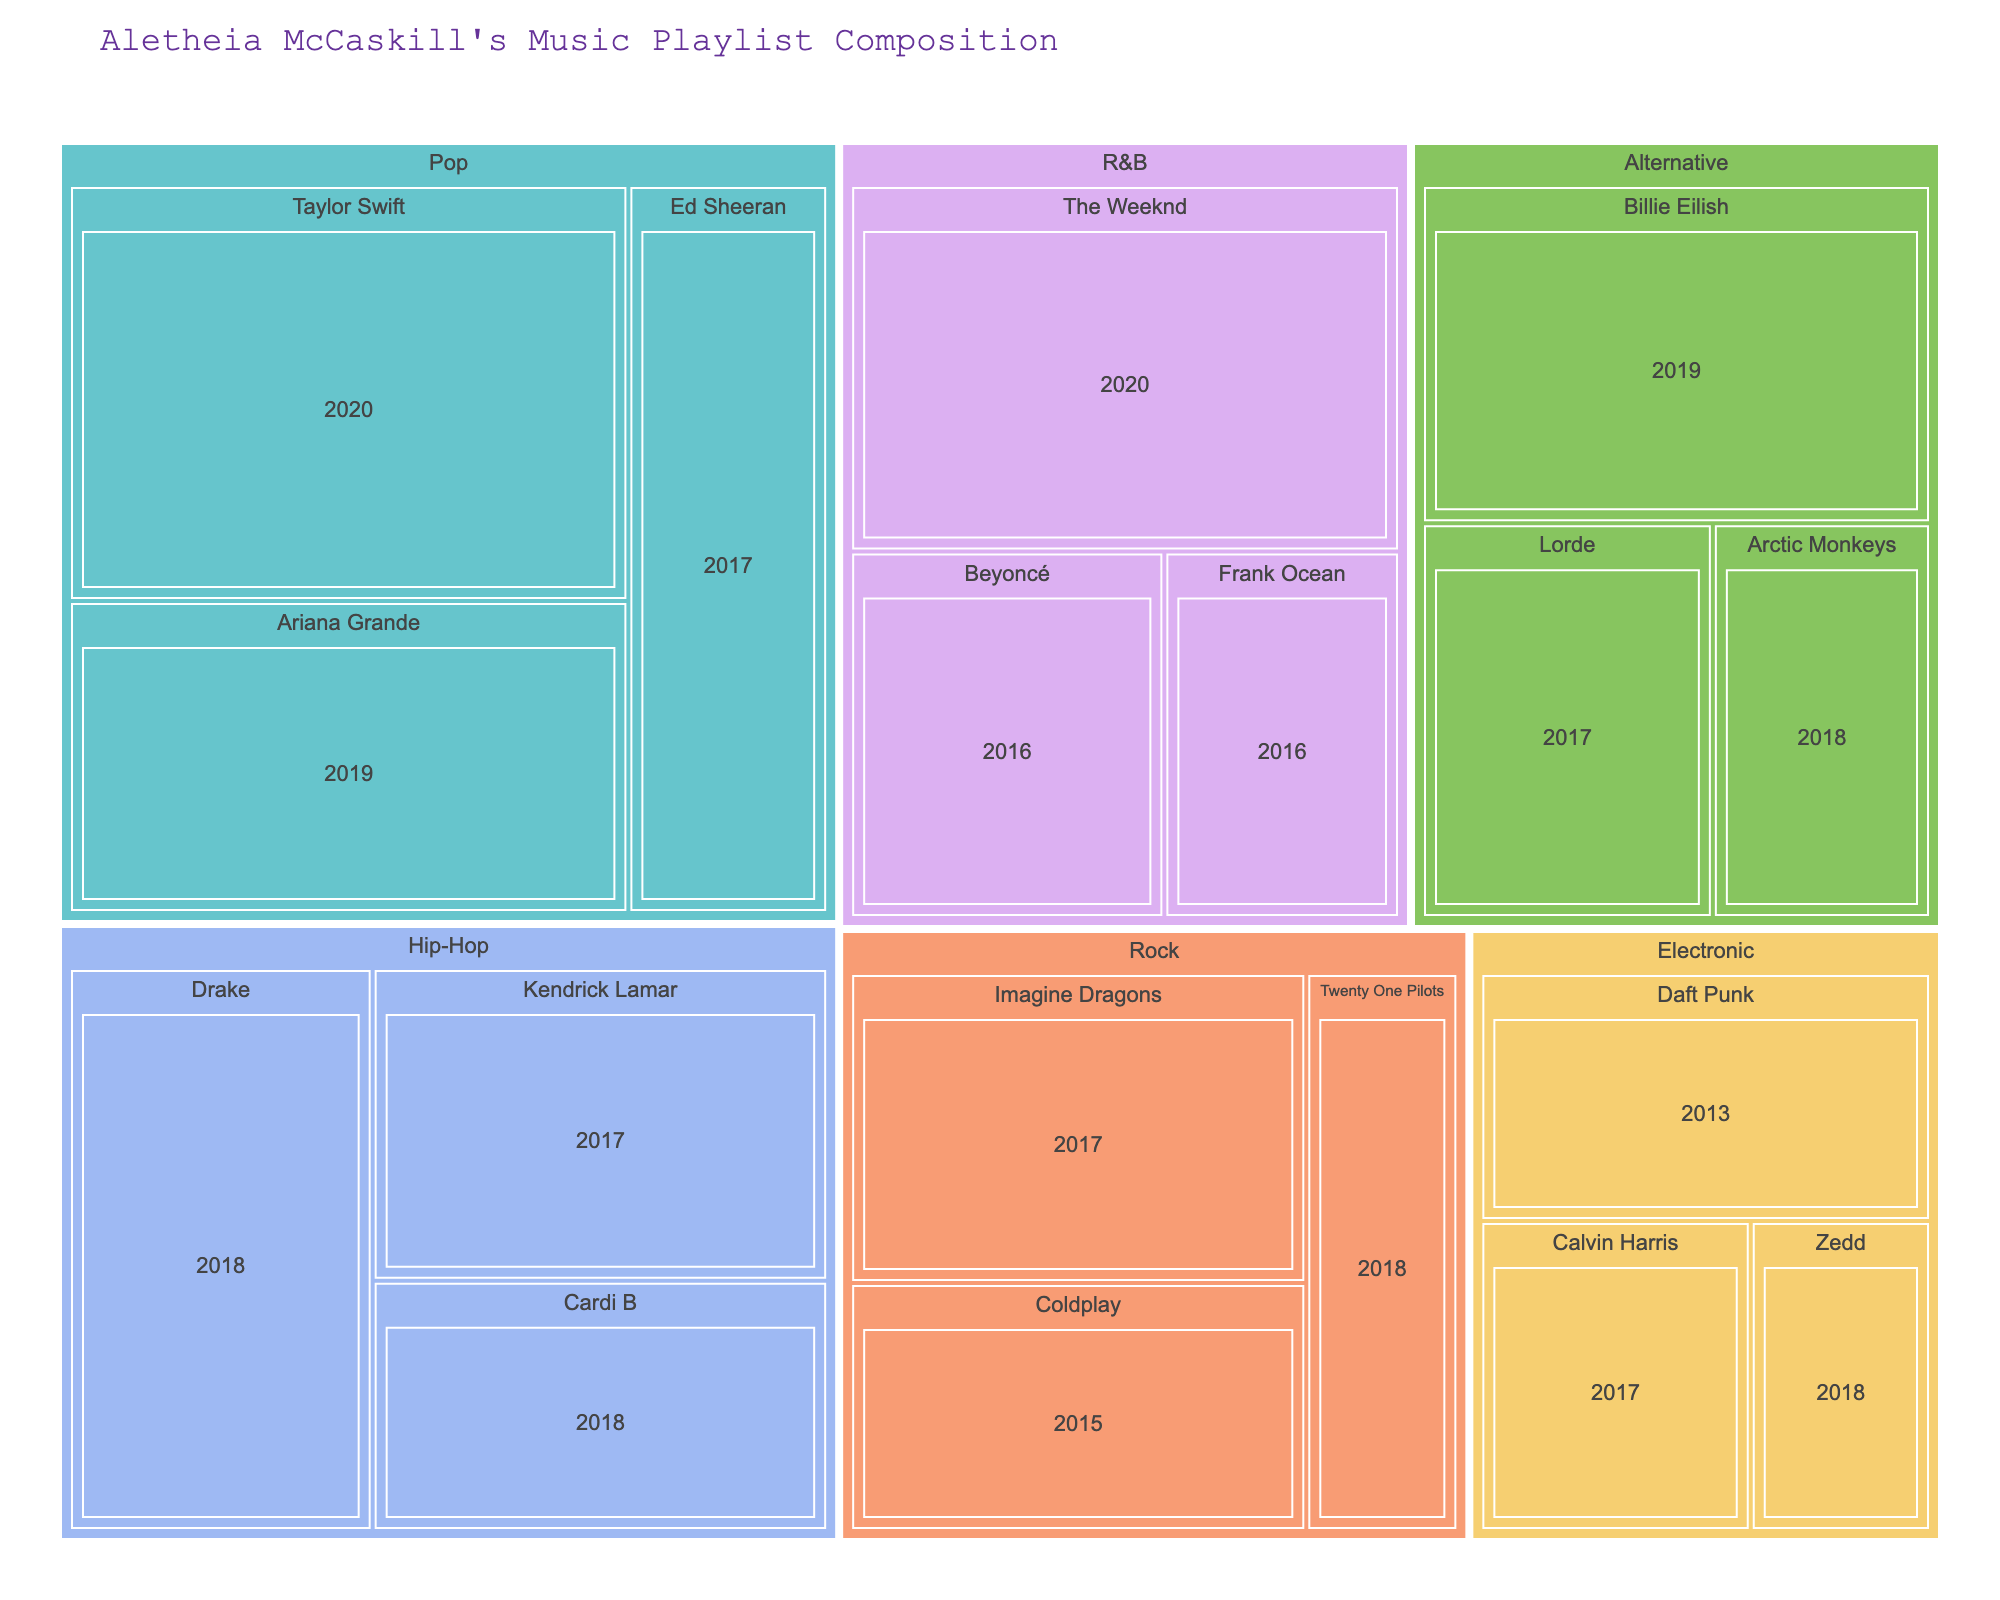What is the title of the treemap? The title of the treemap is found at the top of the figure, usually as the header.
Answer: "Aletheia McCaskill's Music Playlist Composition" Which genre has the most songs? To find the genre with the most songs, look at the size of the sections representing each genre. The largest section corresponds to the genre with the most songs.
Answer: Pop How many songs does Taylor Swift have from her 2020 release? Find the box representing Taylor Swift under the Pop genre and look at the count displayed within or near the box labeled 2020.
Answer: 8 Which year had the most albums released by artists in the Pop genre? Under the Pop genre, examine the release years for each artist and count the total number of songs each year. The year with the highest total is the answer.
Answer: 2020 How many songs are there from the genre Electronic? Find the section representing the Electronic genre and look at the total song count displayed. This is the sum of songs from all artists within this genre.
Answer: 9 Whose songs released in 2016 are included in the playlist? In the R&B section, find the artists with songs from 2016. List each artist found in the corresponding boxes.
Answer: Beyoncé, Frank Ocean Compare the total number of songs in the Hip-Hop and Alternative genres— which has more? Sum the song counts for all artists in Hip-Hop and Alternative sections and compare the totals.
Answer: Hip-Hop (15) has more songs than Alternative (13) Which artist has the least number of songs in the Rock genre? Look at the section for Rock and compare the song counts for each artist under that genre. The artist with the smallest number is the answer.
Answer: Twenty One Pilots What is the difference in the number of songs between The Weeknd and Drake? Find the song count for The Weeknd and Drake, then subtract the smaller count from the larger count. The Weeknd has 7 songs, and Drake has 6 songs. The difference is 1.
Answer: 1 Which genres are represented by colors on the treemap, and what might these colors indicate about the data? Each genre in the treemap is represented by distinct colors. These colors help differentiate genres for easier visual interpretation and grouping of artists within those genres. Colors are randomly assigned rather than indicative of any specific genre characteristic.
Answer: Various distinct colors for each genre 